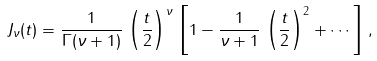Convert formula to latex. <formula><loc_0><loc_0><loc_500><loc_500>J _ { \nu } ( t ) = \frac { 1 } { \Gamma ( \nu + 1 ) } \, \left ( \frac { t } { 2 } \right ) ^ { \nu } \, \left [ 1 - \frac { 1 } { \nu + 1 } \, \left ( \frac { t } { 2 } \right ) ^ { 2 } + \cdots \right ] \, ,</formula> 